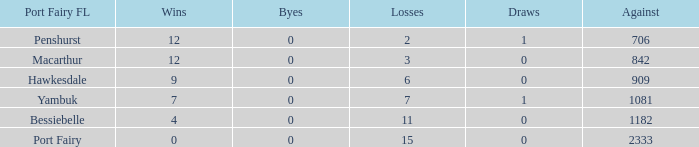How many byes when the draws are less than 0? 0.0. Would you be able to parse every entry in this table? {'header': ['Port Fairy FL', 'Wins', 'Byes', 'Losses', 'Draws', 'Against'], 'rows': [['Penshurst', '12', '0', '2', '1', '706'], ['Macarthur', '12', '0', '3', '0', '842'], ['Hawkesdale', '9', '0', '6', '0', '909'], ['Yambuk', '7', '0', '7', '1', '1081'], ['Bessiebelle', '4', '0', '11', '0', '1182'], ['Port Fairy', '0', '0', '15', '0', '2333']]} 